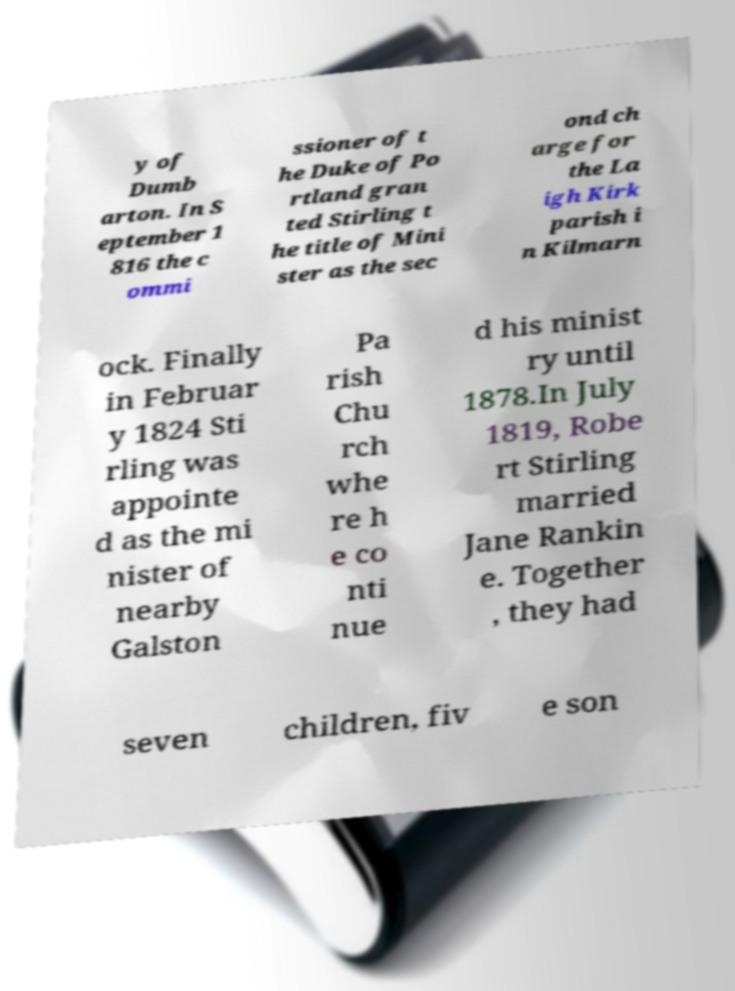Can you accurately transcribe the text from the provided image for me? y of Dumb arton. In S eptember 1 816 the c ommi ssioner of t he Duke of Po rtland gran ted Stirling t he title of Mini ster as the sec ond ch arge for the La igh Kirk parish i n Kilmarn ock. Finally in Februar y 1824 Sti rling was appointe d as the mi nister of nearby Galston Pa rish Chu rch whe re h e co nti nue d his minist ry until 1878.In July 1819, Robe rt Stirling married Jane Rankin e. Together , they had seven children, fiv e son 